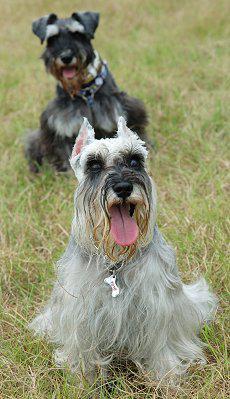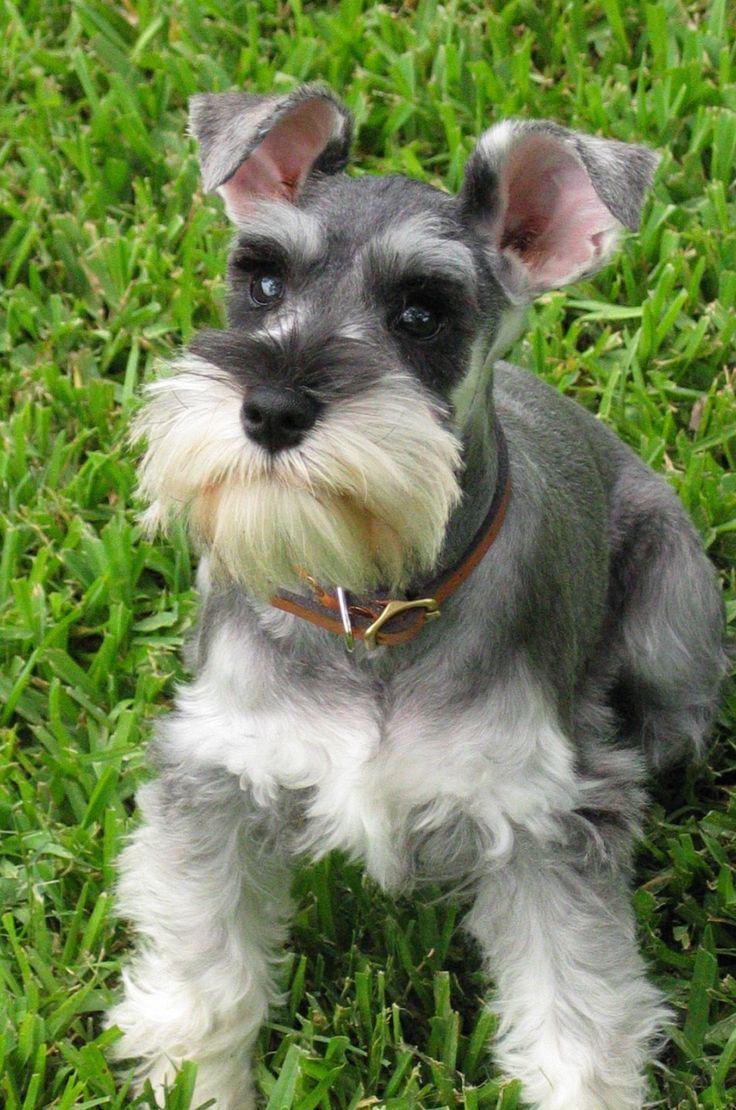The first image is the image on the left, the second image is the image on the right. Analyze the images presented: Is the assertion "There is a dog walking on the pavement in the right image." valid? Answer yes or no. No. The first image is the image on the left, the second image is the image on the right. Evaluate the accuracy of this statement regarding the images: "The dog in the image on the left is indoors". Is it true? Answer yes or no. No. 